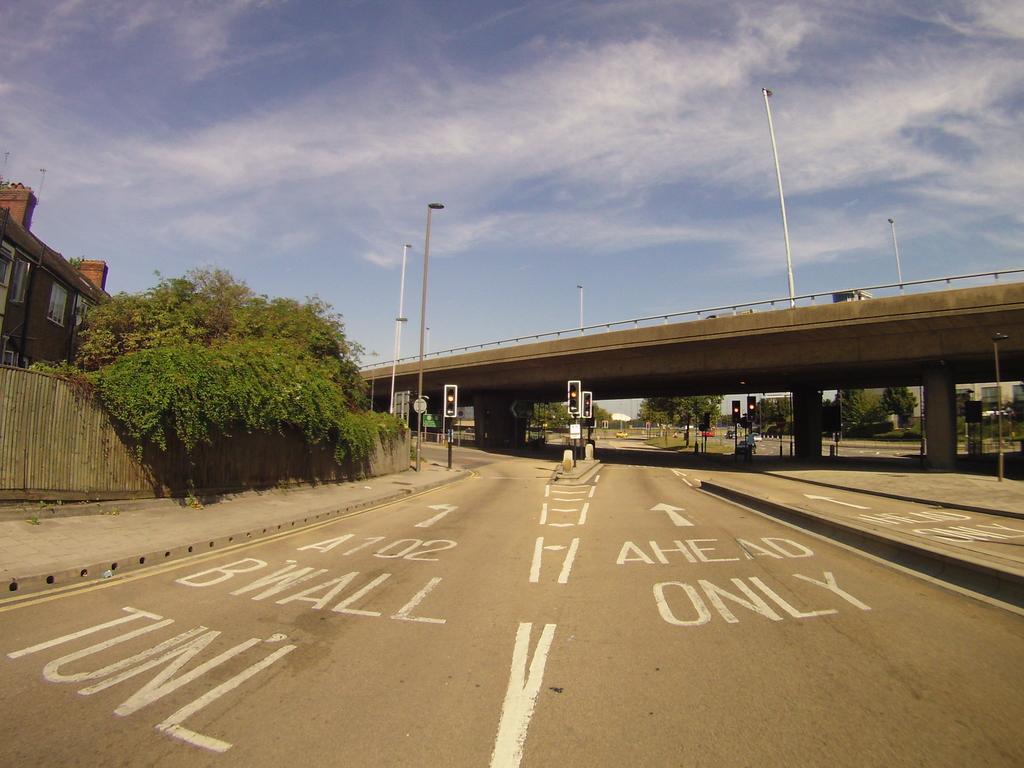Please provide a concise description of this image. In this image we can see texts written on the road. On the left side we can see trees, wall, building and windows. In the background we can see a vehicle on the bridge, street lights, boards on the poles, traffic signal poles, trees, building, windows and clouds in the sky. 